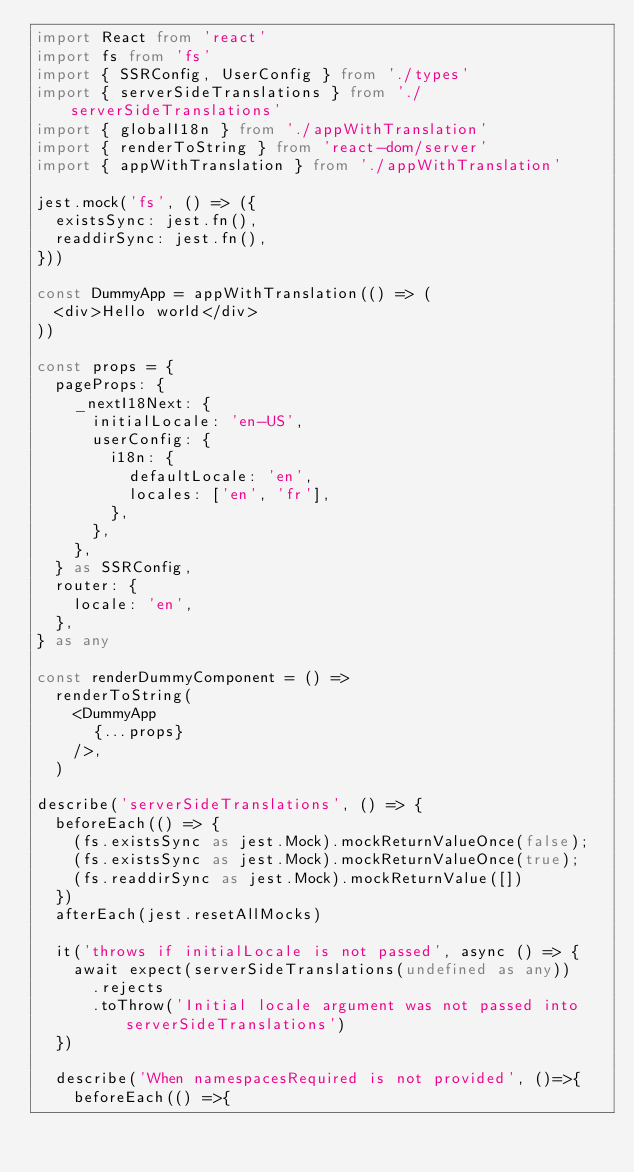Convert code to text. <code><loc_0><loc_0><loc_500><loc_500><_TypeScript_>import React from 'react'
import fs from 'fs'
import { SSRConfig, UserConfig } from './types'
import { serverSideTranslations } from './serverSideTranslations'
import { globalI18n } from './appWithTranslation'
import { renderToString } from 'react-dom/server'
import { appWithTranslation } from './appWithTranslation'

jest.mock('fs', () => ({
  existsSync: jest.fn(),
  readdirSync: jest.fn(),
}))

const DummyApp = appWithTranslation(() => (
  <div>Hello world</div>
))

const props = {
  pageProps: {
    _nextI18Next: {
      initialLocale: 'en-US',
      userConfig: {
        i18n: {
          defaultLocale: 'en',
          locales: ['en', 'fr'],
        },
      },
    },
  } as SSRConfig,
  router: {
    locale: 'en',
  },
} as any

const renderDummyComponent = () =>
  renderToString(
    <DummyApp
      {...props}
    />,
  )

describe('serverSideTranslations', () => {
  beforeEach(() => {
    (fs.existsSync as jest.Mock).mockReturnValueOnce(false);
    (fs.existsSync as jest.Mock).mockReturnValueOnce(true);
    (fs.readdirSync as jest.Mock).mockReturnValue([])
  })
  afterEach(jest.resetAllMocks)

  it('throws if initialLocale is not passed', async () => {
    await expect(serverSideTranslations(undefined as any))
      .rejects
      .toThrow('Initial locale argument was not passed into serverSideTranslations')
  })

  describe('When namespacesRequired is not provided', ()=>{
    beforeEach(() =>{</code> 